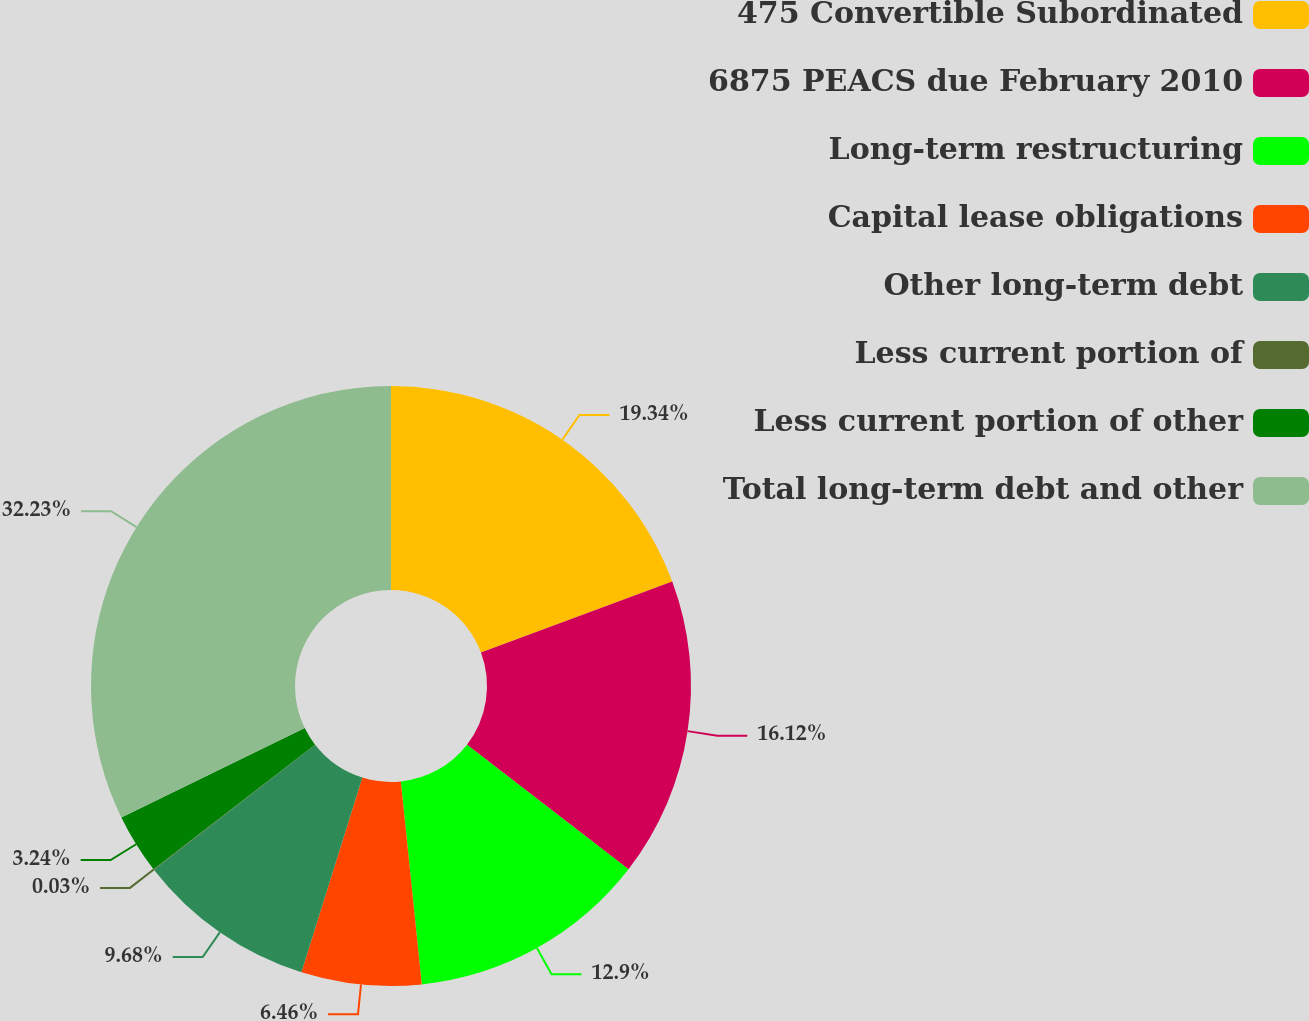<chart> <loc_0><loc_0><loc_500><loc_500><pie_chart><fcel>475 Convertible Subordinated<fcel>6875 PEACS due February 2010<fcel>Long-term restructuring<fcel>Capital lease obligations<fcel>Other long-term debt<fcel>Less current portion of<fcel>Less current portion of other<fcel>Total long-term debt and other<nl><fcel>19.34%<fcel>16.12%<fcel>12.9%<fcel>6.46%<fcel>9.68%<fcel>0.03%<fcel>3.24%<fcel>32.22%<nl></chart> 